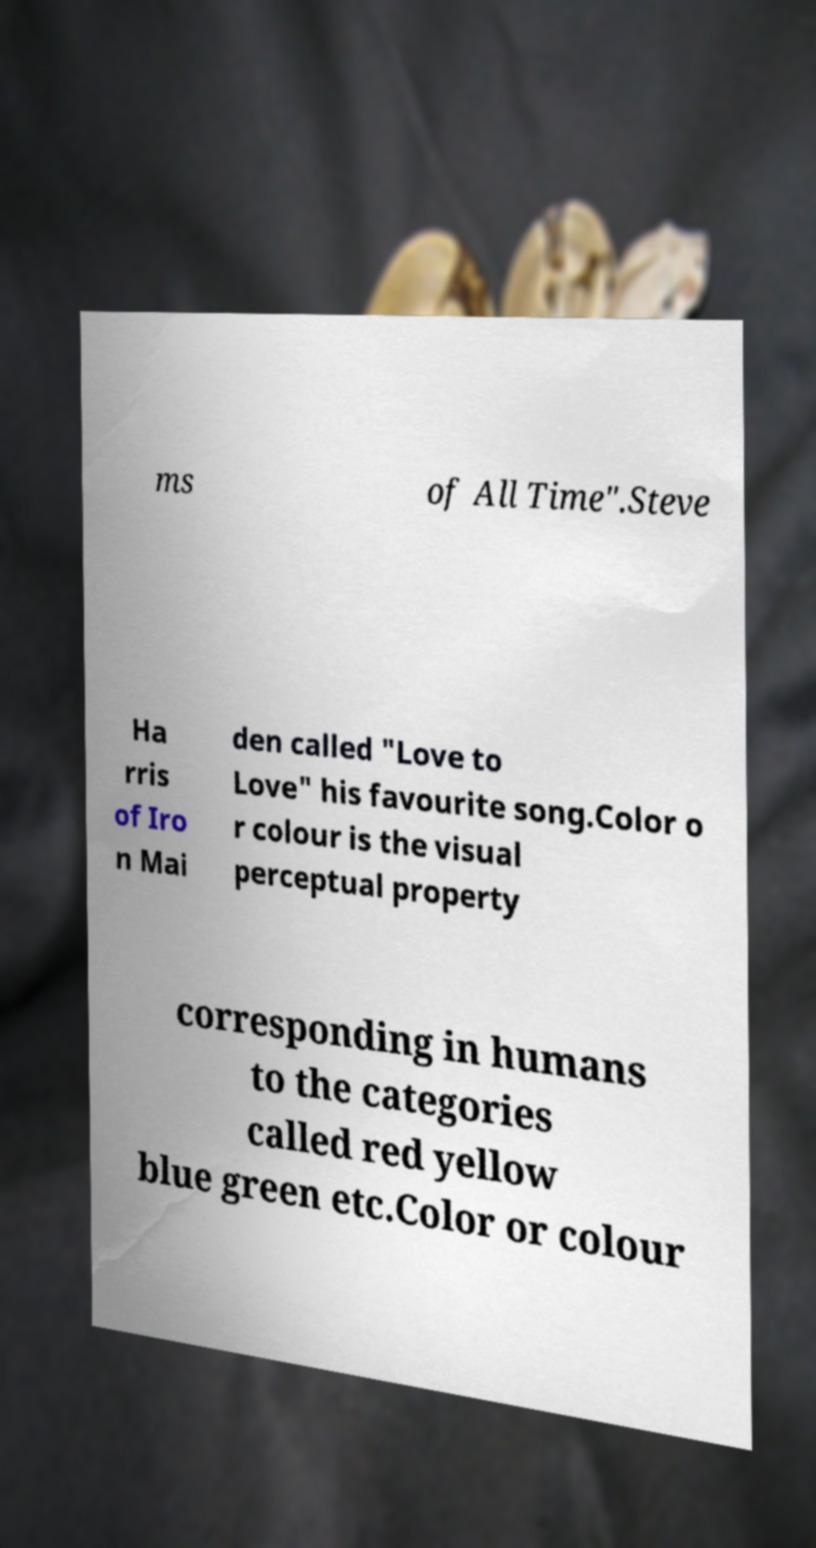Can you read and provide the text displayed in the image?This photo seems to have some interesting text. Can you extract and type it out for me? ms of All Time".Steve Ha rris of Iro n Mai den called "Love to Love" his favourite song.Color o r colour is the visual perceptual property corresponding in humans to the categories called red yellow blue green etc.Color or colour 